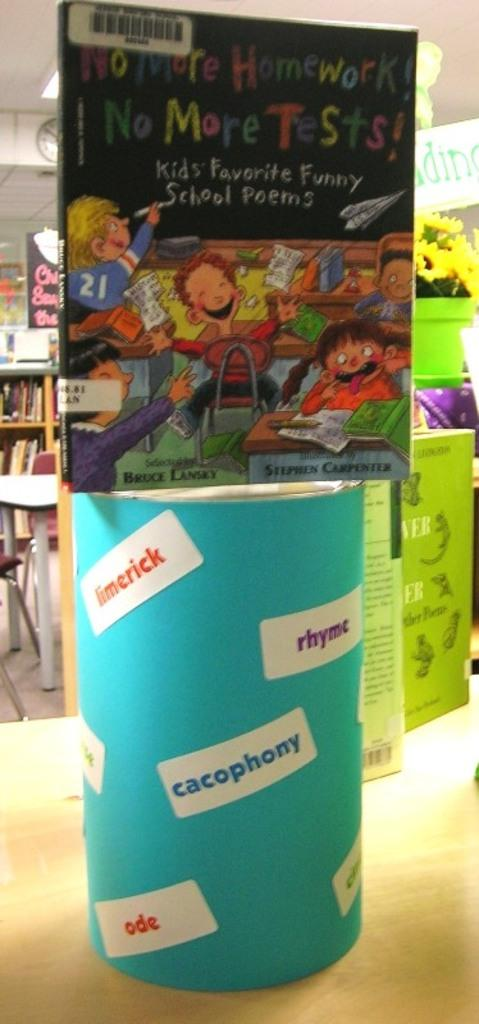<image>
Create a compact narrative representing the image presented. A collection of funny school poems for kids is titled No More Homework! No More Tests! 